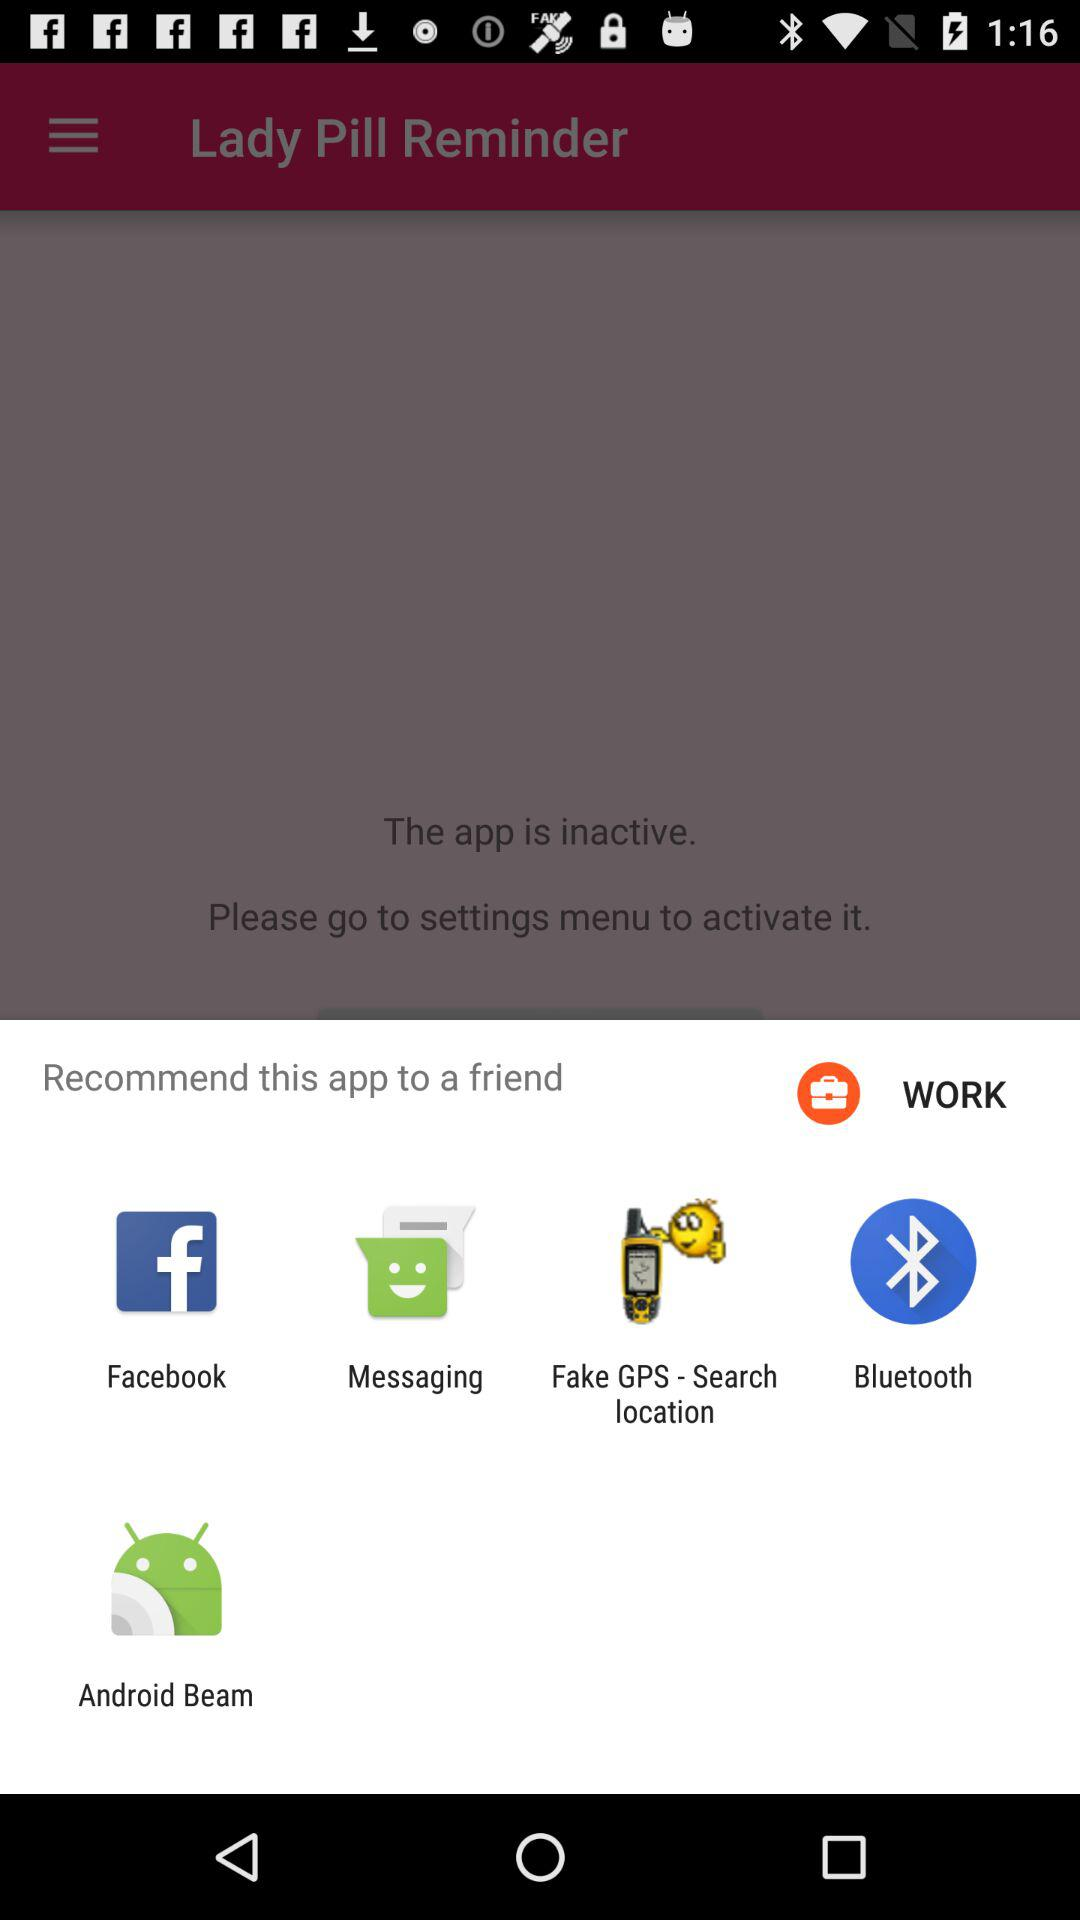When are the different reminders?
When the provided information is insufficient, respond with <no answer>. <no answer> 